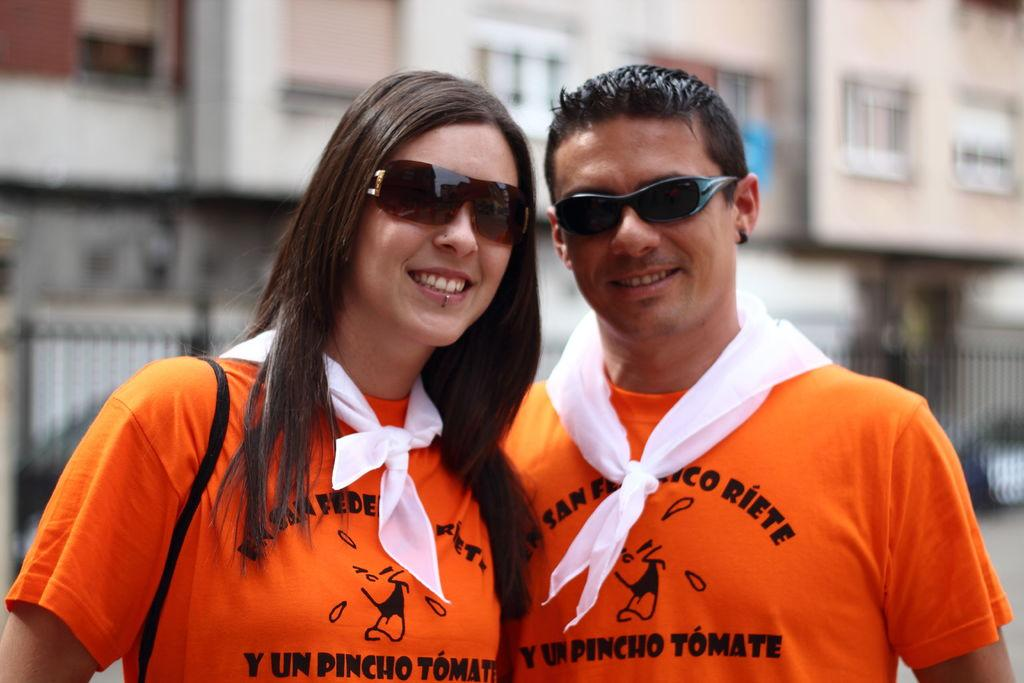How many people are in the image? There are two people in the image. What are the people doing in the image? The people are standing and smiling. What are the people wearing in the image? The people are wearing glasses. What can be seen in the background of the image? The background of the image is blurry, and there is a wall with windows. Can you tell me what type of animal is swimming in the background of the image? There is no animal swimming in the background of the image; the background is blurry and only features a wall with windows. 